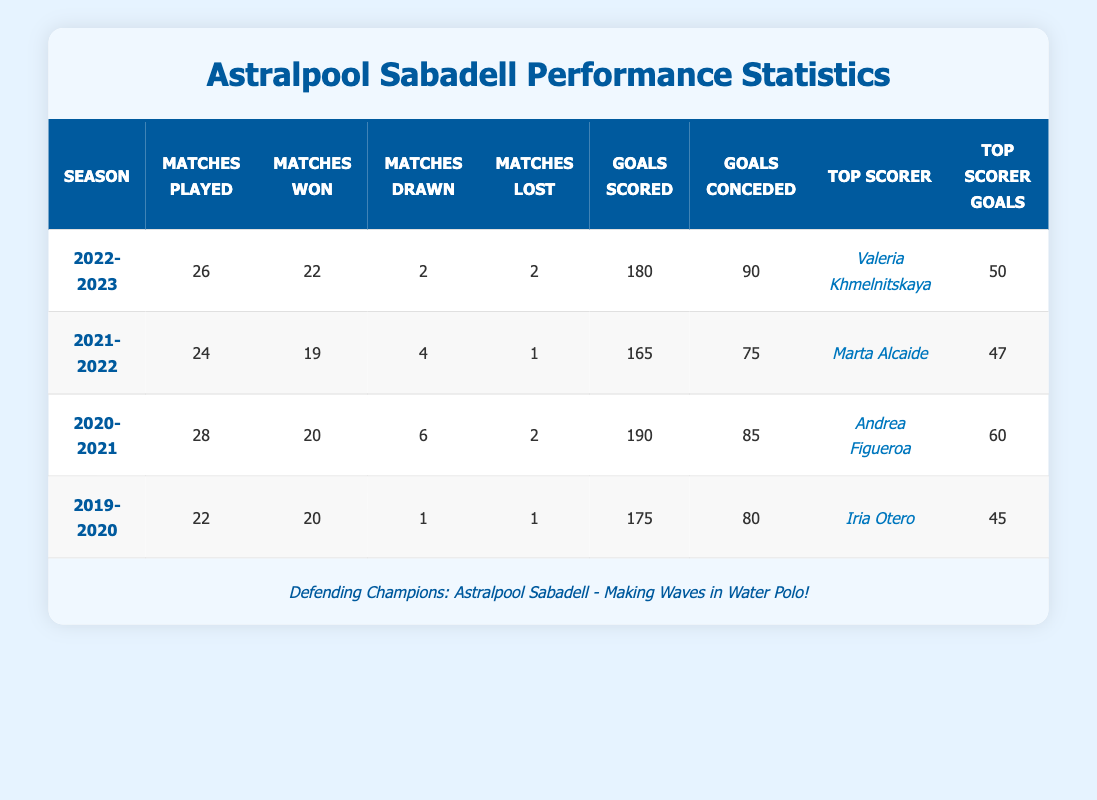What was the top scorer's name in the 2022-2023 season? The table indicates that the top scorer for the 2022-2023 season is listed in the "Top Scorer" column under that season. It shows "Valeria Khmelnitskaya" as the name.
Answer: Valeria Khmelnitskaya How many total goals were scored by Astralpool Sabadell in the 2020-2021 season? Looking at the "Goals Scored" column, the value listed for the 2020-2021 season is 190. Therefore, the total goals scored in that season is 190.
Answer: 190 Did Astralpool Sabadell lose more matches in 2021-2022 than in 2022-2023? In the "Matches Lost" column, the 2021-2022 season shows 1 loss, and the 2022-2023 season shows 2 losses. Since 2 is greater than 1, they did lose more matches in 2022-2023 compared to 2021-2022.
Answer: Yes What is the average number of goals scored per match for the season 2019-2020? To find the average goals scored per match, divide the total goals scored (175) by the number of matches played (22). This results in an average of 175 / 22, which is approximately 7.95.
Answer: 7.95 In which season did Astralpool Sabadell achieve the highest number of wins? The "Matches Won" column shows the wins for each season. The highest value is 22 in the 2022-2023 season. Therefore, that season has the highest wins.
Answer: 2022-2023 What is the difference in goals conceded between the seasons 2021-2022 and 2020-2021? The goals conceded for 2021-2022 is 75 and for 2020-2021 is 85. The difference is calculated as 85 - 75 = 10. Therefore, there were 10 more goals conceded in 2020-2021 compared to 2021-2022.
Answer: 10 How many matches did Astralpool Sabadell draw in total from 2019-2020 to 2022-2023? From the "Matches Drawn" column, the total drawn matches are 1 (2019-2020) + 4 (2021-2022) + 2 (2022-2023) = 7. Thus, they had 7 drawn matches total in that range.
Answer: 7 Which seasons had the same number of matches played? Checking the "Matches Played" column, both 2021-2022 and 2019-2020 have 24 matches played. Therefore, these two seasons had the same number of matches played.
Answer: 2021-2022 and 2019-2020 Was the top scorer in 2020-2021 Andrea Figueroa? The table indicates that Andrea Figueroa is indeed listed as the top scorer for the 2020-2021 season in the "Top Scorer" column. Therefore, this statement is true.
Answer: Yes 